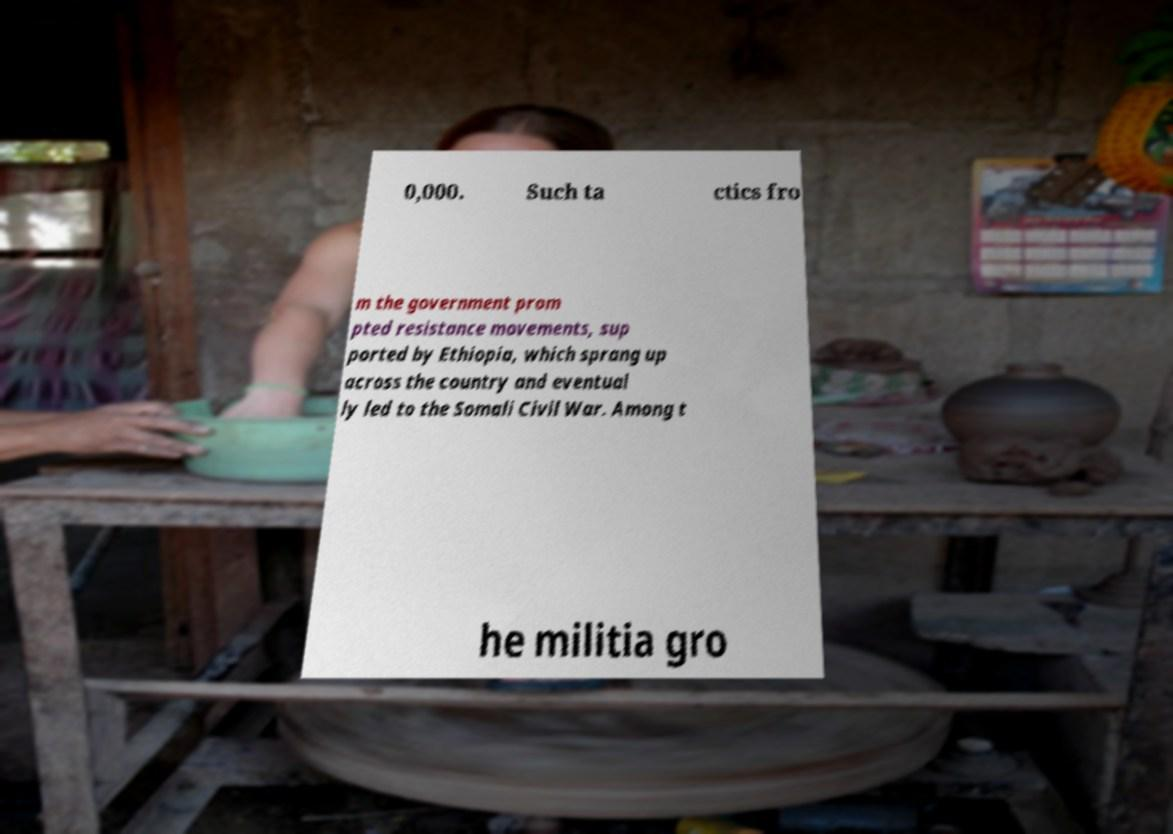For documentation purposes, I need the text within this image transcribed. Could you provide that? 0,000. Such ta ctics fro m the government prom pted resistance movements, sup ported by Ethiopia, which sprang up across the country and eventual ly led to the Somali Civil War. Among t he militia gro 